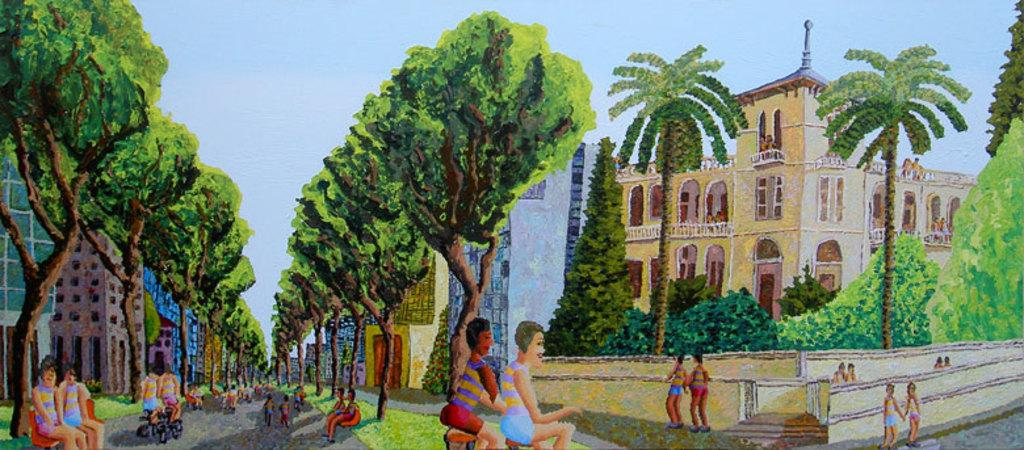What type of image is being described? The image is a painted image. What structures are depicted in the painted image? There are buildings depicted in the painted image. What natural elements are depicted in the painted image? There are trees depicted in the painted image. Who or what else is depicted in the painted image? There are people depicted in the painted image. What type of lead is used in the painting of the image? There is no information provided about the materials used in the painting, so it is impossible to determine the type of lead used. 